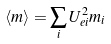Convert formula to latex. <formula><loc_0><loc_0><loc_500><loc_500>\langle m \rangle = \sum _ { i } U _ { e i } ^ { 2 } m _ { i }</formula> 